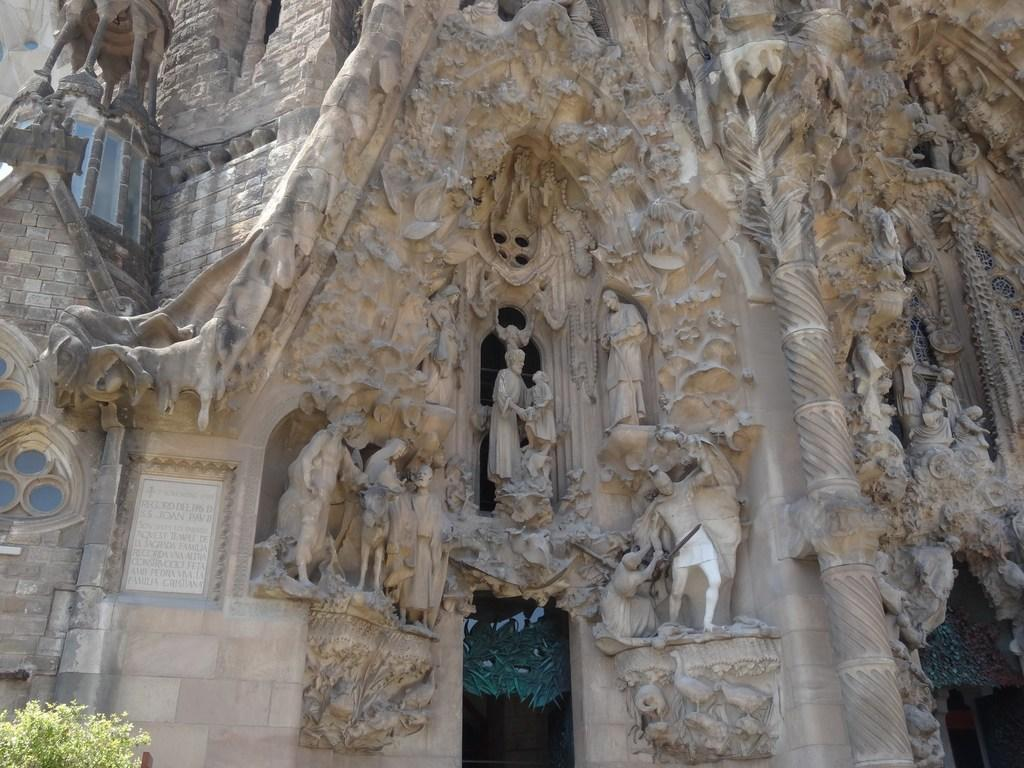What can be seen on the walls of the building in the image? There are statues on the walls of the building in the image. What else is visible in the image besides the statues? There is text and a plant visible in the image. How many pigs are sitting on the plant in the image? There are no pigs present in the image; it features statues on the walls of a building, text, and a plant. What type of dolls can be seen interacting with the statues in the image? There are no dolls present in the image; it features statues on the walls of a building, text, and a plant. 